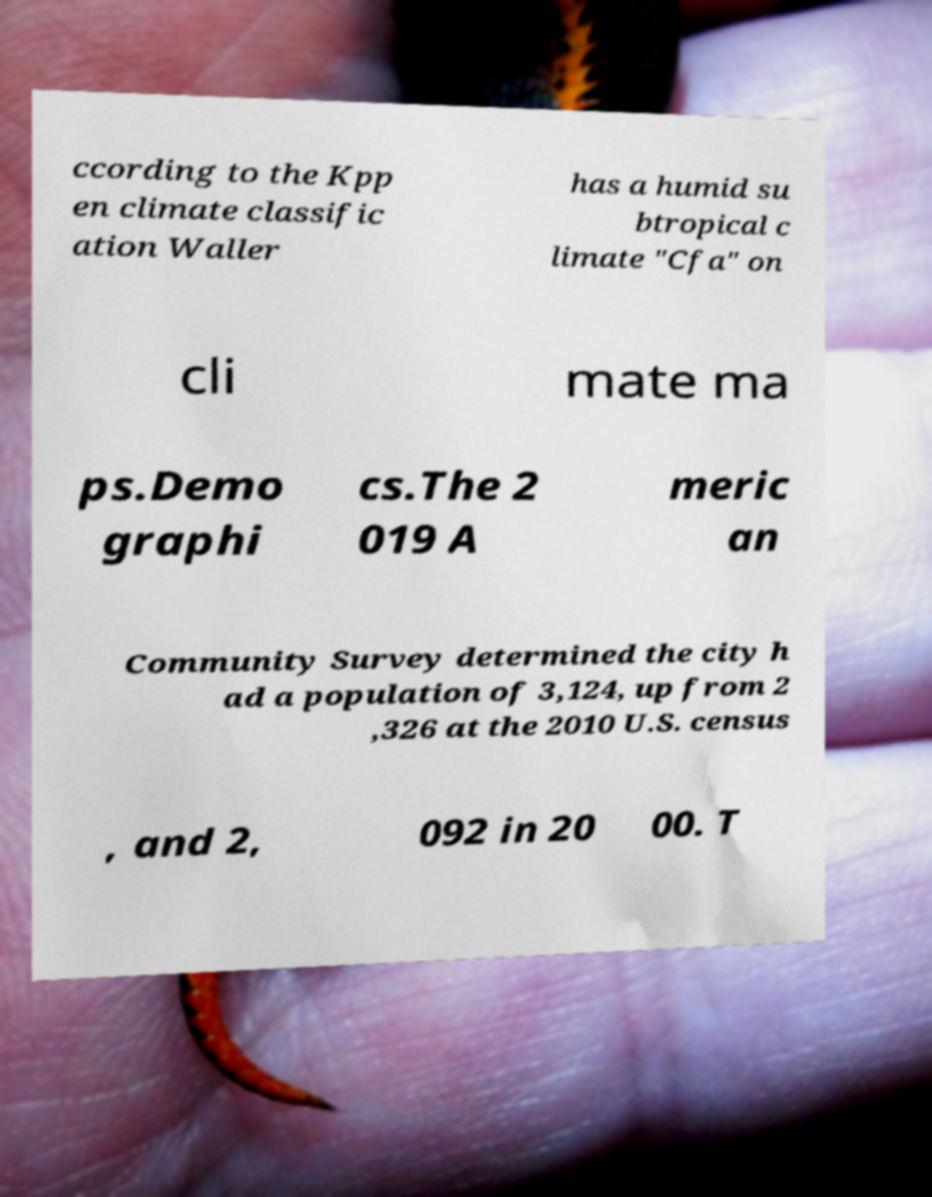Please read and relay the text visible in this image. What does it say? ccording to the Kpp en climate classific ation Waller has a humid su btropical c limate "Cfa" on cli mate ma ps.Demo graphi cs.The 2 019 A meric an Community Survey determined the city h ad a population of 3,124, up from 2 ,326 at the 2010 U.S. census , and 2, 092 in 20 00. T 